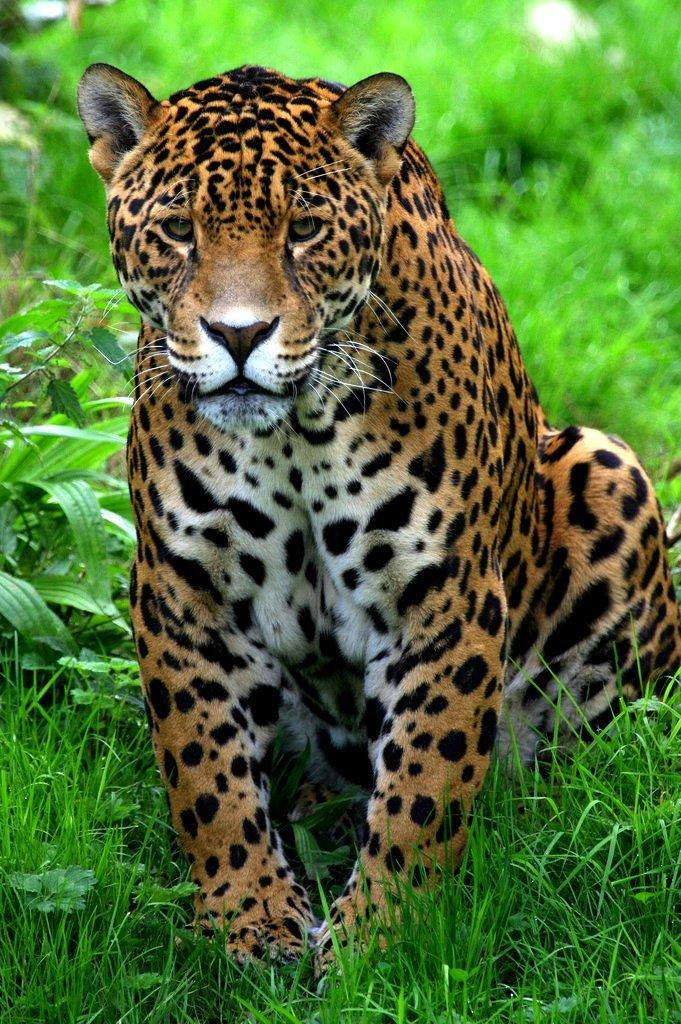What animal is in the image? There is a tiger in the image. What is the tiger doing in the image? The tiger is sitting on the ground. What type of environment is visible in the background of the image? There is grass visible in the background of the image. How many sisters are present at the dinner table in the image? There are no women, sisters, or dinner table present in the image; it features a tiger sitting on the ground with grass in the background. 